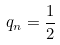<formula> <loc_0><loc_0><loc_500><loc_500>q _ { n } = \frac { 1 } { 2 }</formula> 